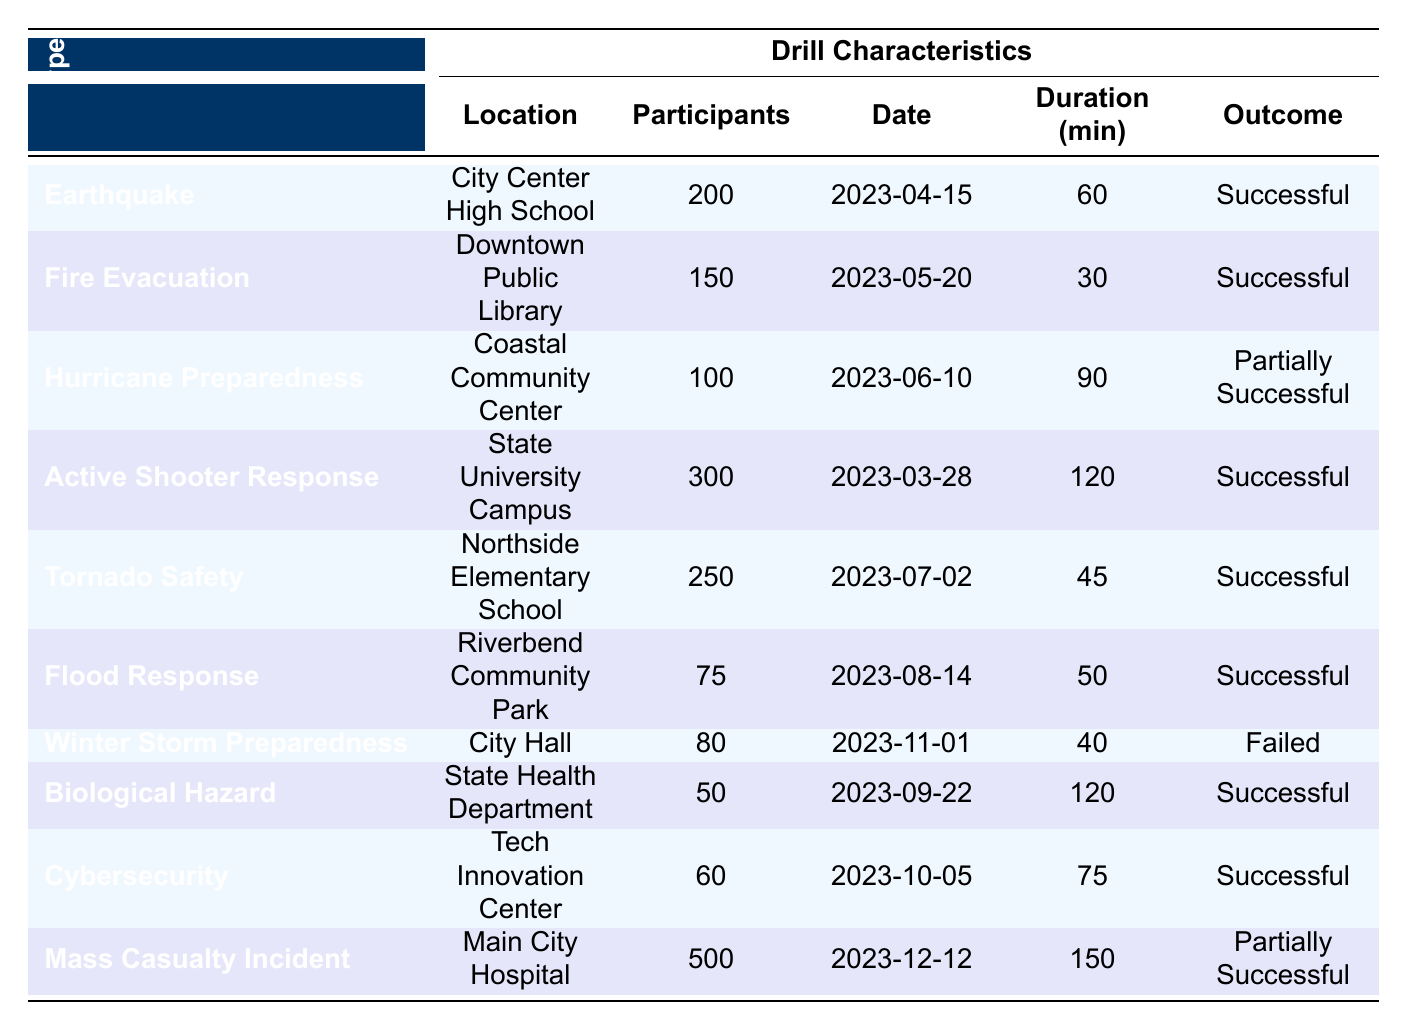What is the outcome of the Earthquake Drill? The table shows that the Earthquake Drill conducted at City Center High School had an outcome of "Successful."
Answer: Successful How many participants were in the Fire Evacuation Drill? According to the table, the Fire Evacuation Drill held at Downtown Public Library had 150 participants.
Answer: 150 Which drill had the longest duration, and what was that duration? The Mass Casualty Incident Drill at Main City Hospital lasted 150 minutes, which is the longest duration of all listed drills.
Answer: 150 minutes Did the Winter Storm Preparedness Drill succeed? The outcome listed for the Winter Storm Preparedness Drill held at City Hall is "Failed," indicating that it did not succeed.
Answer: No What is the average number of participants across all emergency drills? To find the average, we first sum the participants: 200 + 150 + 100 + 300 + 250 + 75 + 80 + 50 + 60 + 500 = 1865. There are 10 drills, so we divide: 1865 / 10 = 186.5.
Answer: 186.5 How many drills had an outcome of "Successful"? By reviewing the outcomes in the table, we find that 7 out of the 10 drills were marked as "Successful."
Answer: 7 Which drill took place on the latest date, and what was that date? The last drill listed is the Mass Casualty Incident Drill on December 12, 2023, which is the latest date among the drills.
Answer: December 12, 2023 Was the outcome of the Hurricane Preparedness Drill "Successful"? The table indicates that the outcome of the Hurricane Preparedness Drill was "Partially Successful," so it was not fully "Successful."
Answer: No How many drills were conducted in schools? The table reveals that three drills were conducted in schools: Earthquake Drill at City Center High School, Tornado Safety Drill at Northside Elementary School, and Active Shooter Response Drill at State University Campus.
Answer: 3 